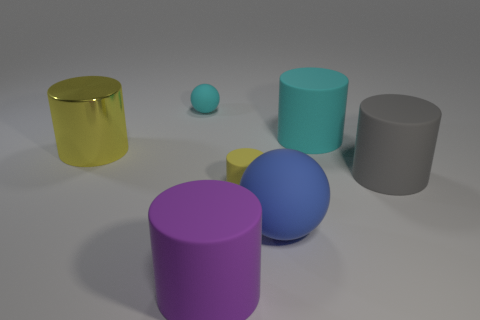There is another cylinder that is the same color as the big shiny cylinder; what is it made of?
Provide a succinct answer. Rubber. What number of other objects are the same color as the metal thing?
Your answer should be compact. 1. Is there a small yellow cylinder made of the same material as the cyan ball?
Offer a very short reply. Yes. What shape is the small cyan matte thing?
Provide a succinct answer. Sphere. What color is the other tiny cylinder that is the same material as the purple cylinder?
Make the answer very short. Yellow. What number of blue things are either large rubber balls or small spheres?
Make the answer very short. 1. Are there more large purple rubber things than large cyan metallic objects?
Keep it short and to the point. Yes. What number of objects are either things that are in front of the cyan rubber cylinder or matte things to the right of the big blue matte sphere?
Your answer should be very brief. 6. What is the color of the metal cylinder that is the same size as the gray object?
Your response must be concise. Yellow. Does the large cyan thing have the same material as the large yellow object?
Your response must be concise. No. 